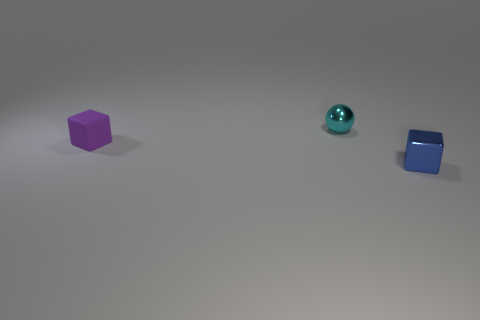How many other objects are the same shape as the purple object?
Keep it short and to the point. 1. How many things are red rubber cylinders or cubes?
Give a very brief answer. 2. There is a small purple rubber thing that is to the left of the tiny metal thing in front of the small sphere; what shape is it?
Give a very brief answer. Cube. Is the number of tiny purple matte objects less than the number of big green metal cylinders?
Ensure brevity in your answer.  No. What size is the object that is both in front of the tiny metallic sphere and to the left of the metal block?
Ensure brevity in your answer.  Small. How many matte things are in front of the small purple rubber object?
Your response must be concise. 0. Is the number of cyan things greater than the number of metallic objects?
Give a very brief answer. No. What is the shape of the small object that is both in front of the tiny metal sphere and to the right of the tiny purple cube?
Provide a succinct answer. Cube. Are there any big blue matte cylinders?
Your answer should be compact. No. What is the material of the other object that is the same shape as the blue thing?
Provide a short and direct response. Rubber. 